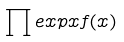<formula> <loc_0><loc_0><loc_500><loc_500>\prod e x p x f ( x )</formula> 